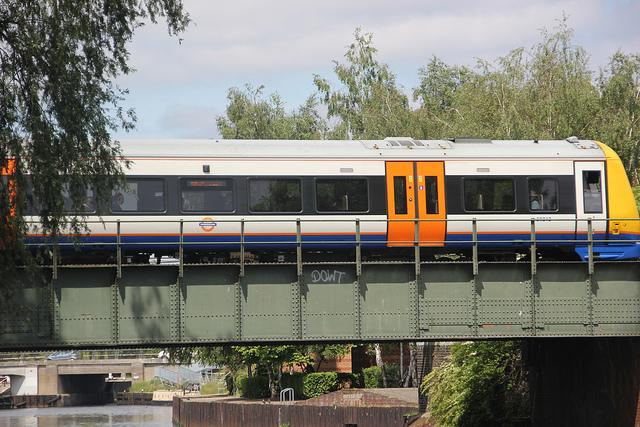The train gliding on what in order to move? tracks 